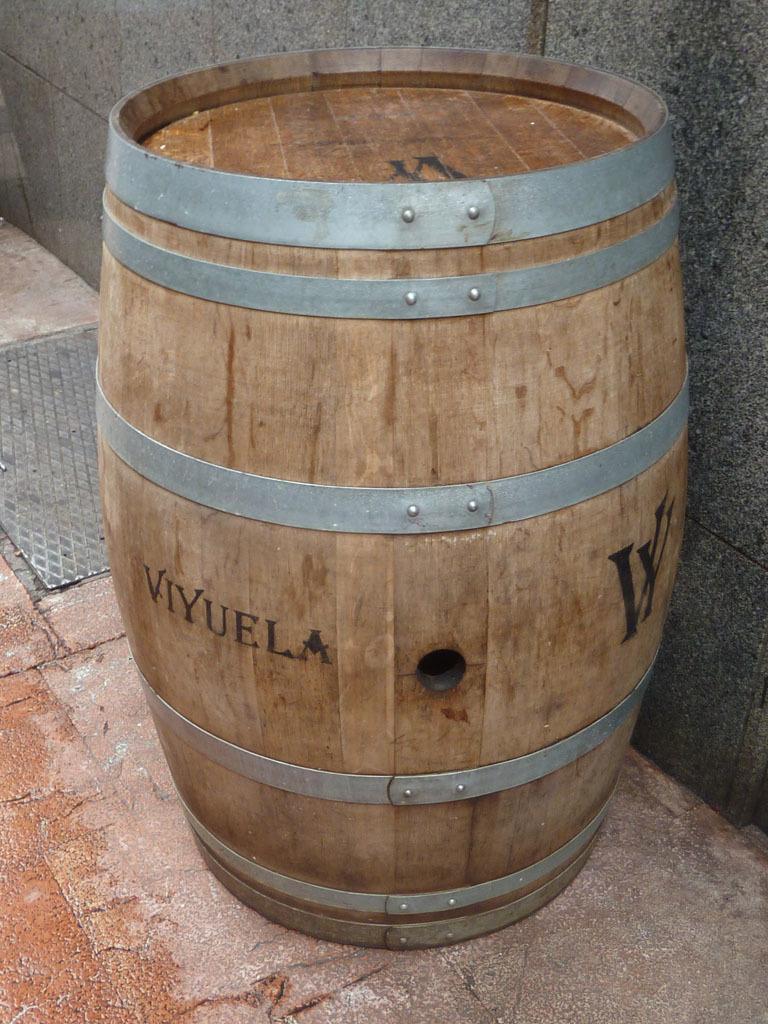In one or two sentences, can you explain what this image depicts? In this picture, we can see a wooden barrel with some text on the surface. Background there is a wall. On the left side of the image, we can see a steel lid. 